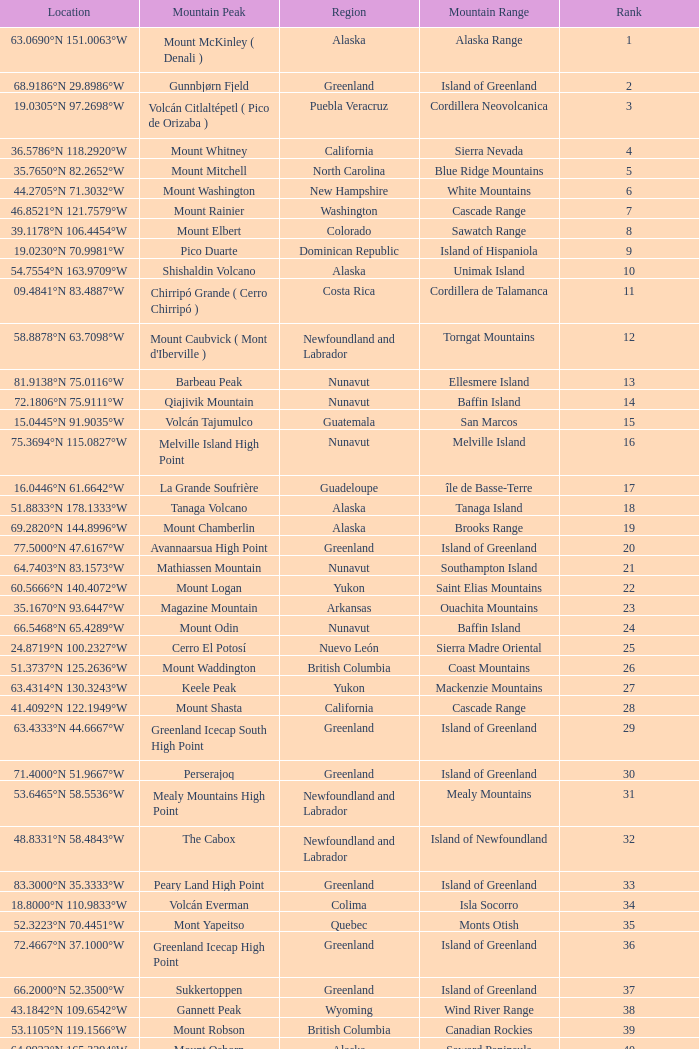Name the Mountain Peak which has a Rank of 62? Cerro Nube ( Quie Yelaag ). 